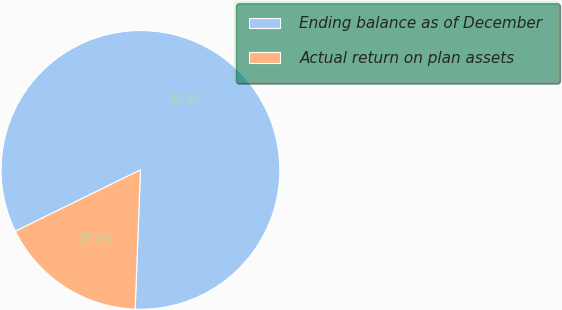Convert chart to OTSL. <chart><loc_0><loc_0><loc_500><loc_500><pie_chart><fcel>Ending balance as of December<fcel>Actual return on plan assets<nl><fcel>82.86%<fcel>17.14%<nl></chart> 